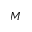<formula> <loc_0><loc_0><loc_500><loc_500>M</formula> 